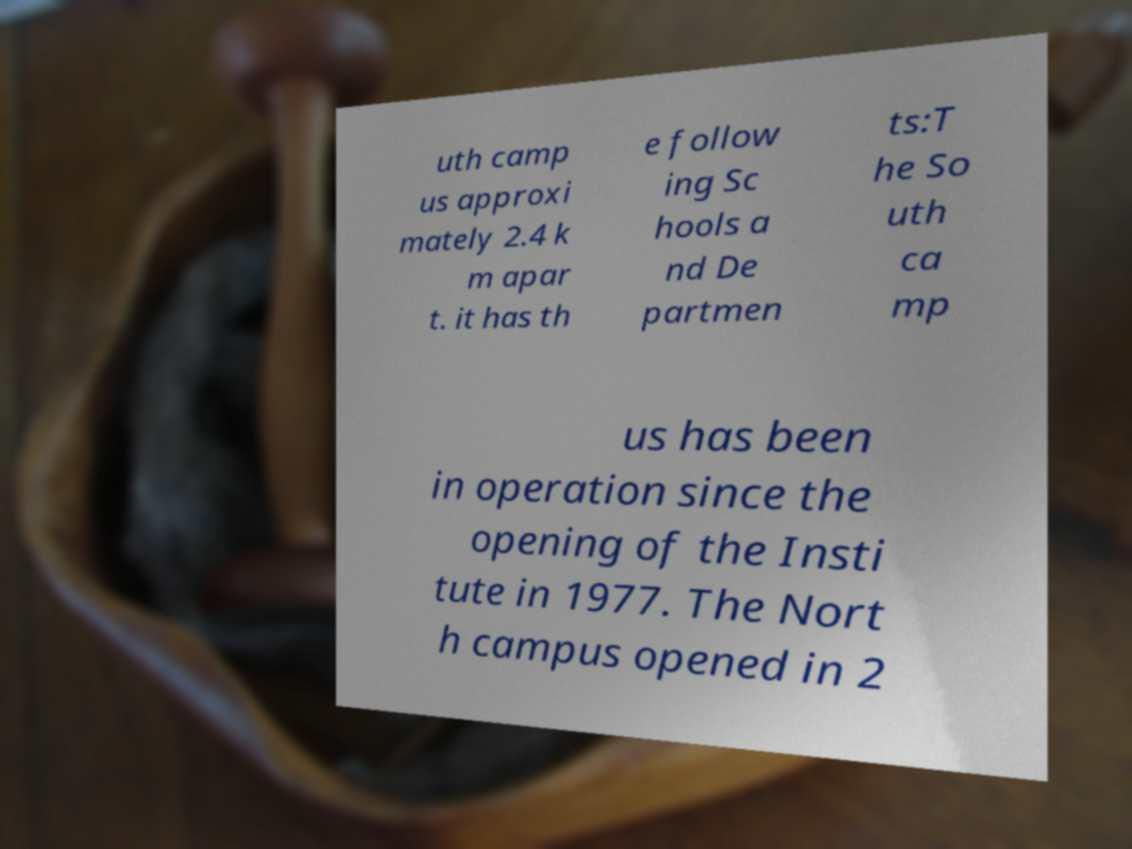For documentation purposes, I need the text within this image transcribed. Could you provide that? uth camp us approxi mately 2.4 k m apar t. it has th e follow ing Sc hools a nd De partmen ts:T he So uth ca mp us has been in operation since the opening of the Insti tute in 1977. The Nort h campus opened in 2 